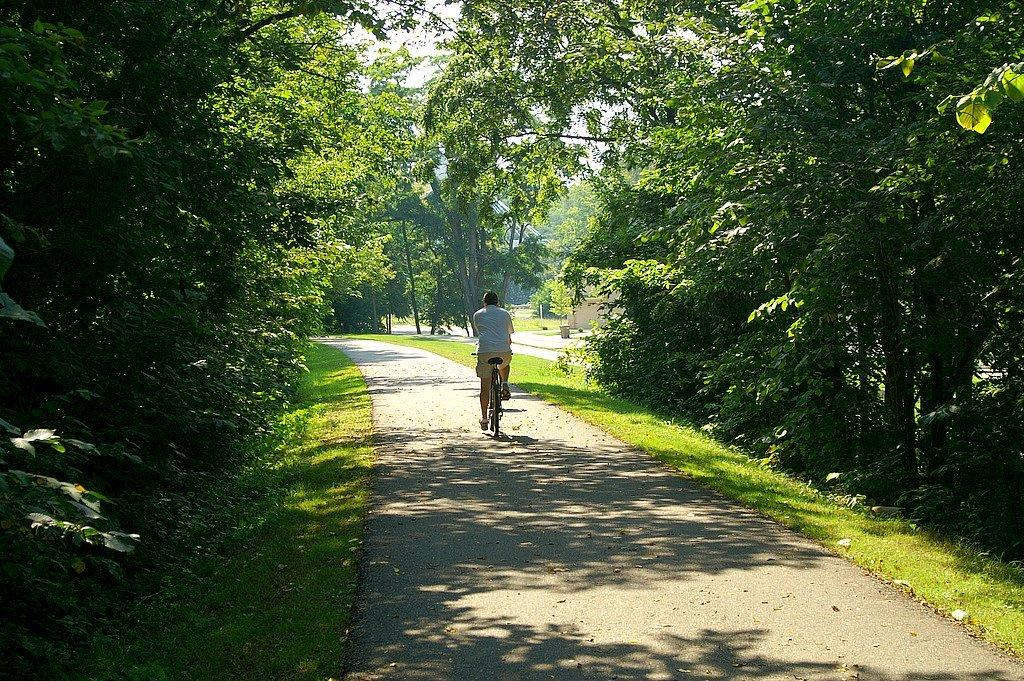What is the person in the image doing? There is a person riding a cycle on the road in the image. What can be seen in the background of the image? Plants and trees are visible in the image. What type of structure is present in the image? There is a house in the image. What is visible above the person and the house? The sky is visible in the image. Can you describe the harbor in the image? There is no harbor present in the image; it features a person riding a cycle on the road, plants and trees, a house, and the sky. 